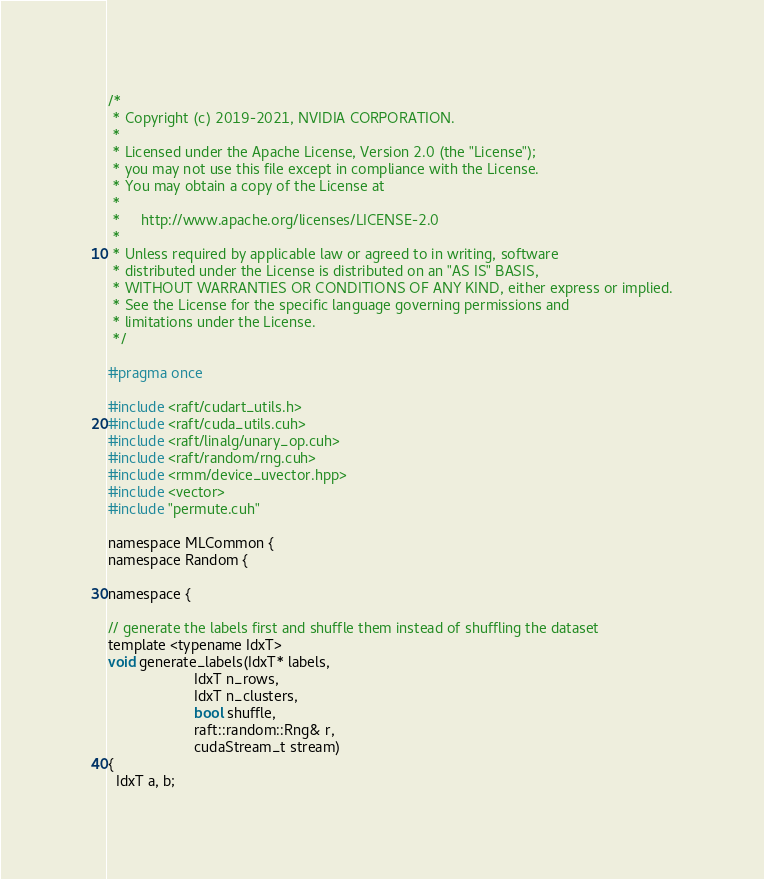Convert code to text. <code><loc_0><loc_0><loc_500><loc_500><_Cuda_>/*
 * Copyright (c) 2019-2021, NVIDIA CORPORATION.
 *
 * Licensed under the Apache License, Version 2.0 (the "License");
 * you may not use this file except in compliance with the License.
 * You may obtain a copy of the License at
 *
 *     http://www.apache.org/licenses/LICENSE-2.0
 *
 * Unless required by applicable law or agreed to in writing, software
 * distributed under the License is distributed on an "AS IS" BASIS,
 * WITHOUT WARRANTIES OR CONDITIONS OF ANY KIND, either express or implied.
 * See the License for the specific language governing permissions and
 * limitations under the License.
 */

#pragma once

#include <raft/cudart_utils.h>
#include <raft/cuda_utils.cuh>
#include <raft/linalg/unary_op.cuh>
#include <raft/random/rng.cuh>
#include <rmm/device_uvector.hpp>
#include <vector>
#include "permute.cuh"

namespace MLCommon {
namespace Random {

namespace {

// generate the labels first and shuffle them instead of shuffling the dataset
template <typename IdxT>
void generate_labels(IdxT* labels,
                     IdxT n_rows,
                     IdxT n_clusters,
                     bool shuffle,
                     raft::random::Rng& r,
                     cudaStream_t stream)
{
  IdxT a, b;</code> 